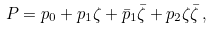<formula> <loc_0><loc_0><loc_500><loc_500>P = p _ { 0 } + p _ { 1 } \zeta + \bar { p } _ { 1 } \bar { \zeta } + p _ { 2 } \zeta \bar { \zeta } \, ,</formula> 